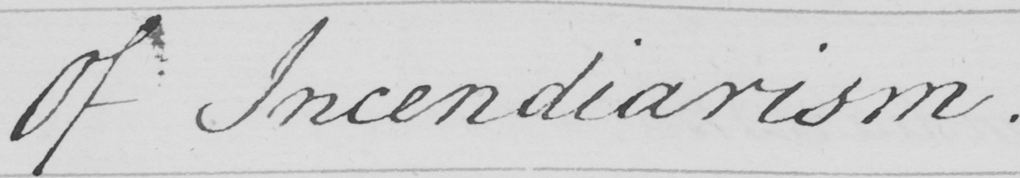What does this handwritten line say? Of Incendiarism . 